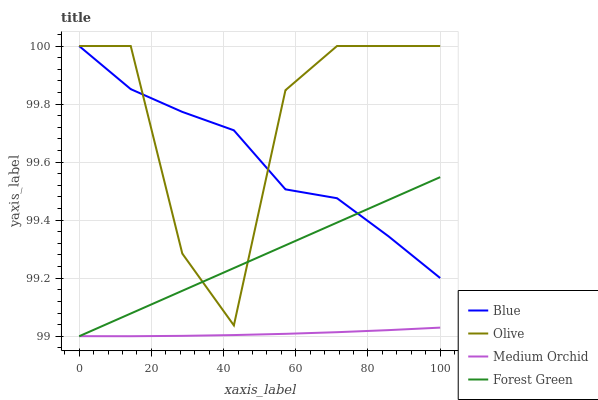Does Medium Orchid have the minimum area under the curve?
Answer yes or no. Yes. Does Olive have the maximum area under the curve?
Answer yes or no. Yes. Does Forest Green have the minimum area under the curve?
Answer yes or no. No. Does Forest Green have the maximum area under the curve?
Answer yes or no. No. Is Forest Green the smoothest?
Answer yes or no. Yes. Is Olive the roughest?
Answer yes or no. Yes. Is Olive the smoothest?
Answer yes or no. No. Is Forest Green the roughest?
Answer yes or no. No. Does Forest Green have the lowest value?
Answer yes or no. Yes. Does Olive have the lowest value?
Answer yes or no. No. Does Olive have the highest value?
Answer yes or no. Yes. Does Forest Green have the highest value?
Answer yes or no. No. Is Medium Orchid less than Olive?
Answer yes or no. Yes. Is Blue greater than Medium Orchid?
Answer yes or no. Yes. Does Blue intersect Forest Green?
Answer yes or no. Yes. Is Blue less than Forest Green?
Answer yes or no. No. Is Blue greater than Forest Green?
Answer yes or no. No. Does Medium Orchid intersect Olive?
Answer yes or no. No. 